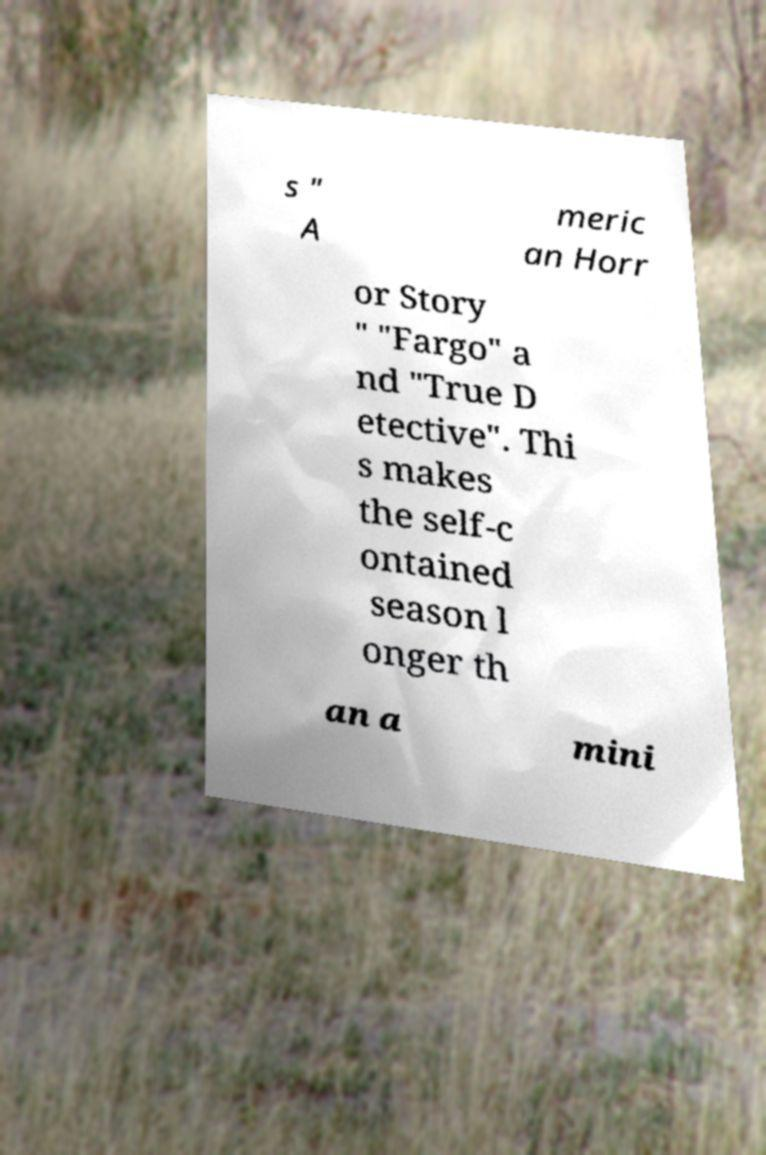Could you assist in decoding the text presented in this image and type it out clearly? s " A meric an Horr or Story " "Fargo" a nd "True D etective". Thi s makes the self-c ontained season l onger th an a mini 